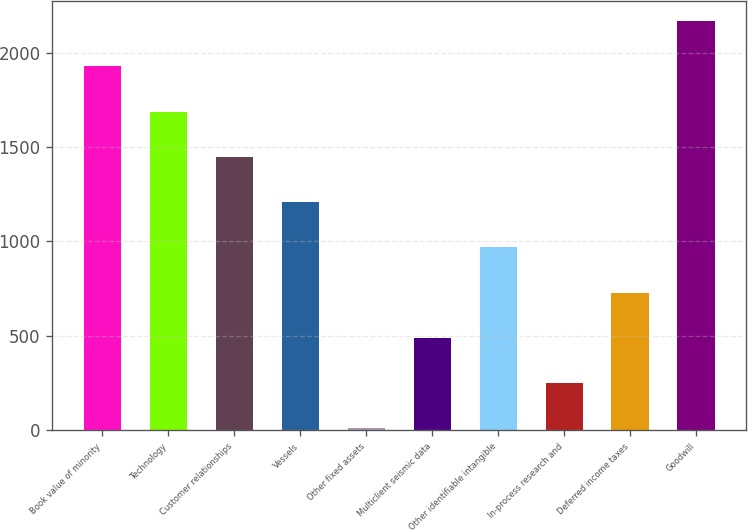<chart> <loc_0><loc_0><loc_500><loc_500><bar_chart><fcel>Book value of minority<fcel>Technology<fcel>Customer relationships<fcel>Vessels<fcel>Other fixed assets<fcel>Multiclient seismic data<fcel>Other identifiable intangible<fcel>In-process research and<fcel>Deferred income taxes<fcel>Goodwill<nl><fcel>1926.8<fcel>1687.2<fcel>1447.6<fcel>1208<fcel>10<fcel>489.2<fcel>968.4<fcel>249.6<fcel>728.8<fcel>2166.4<nl></chart> 